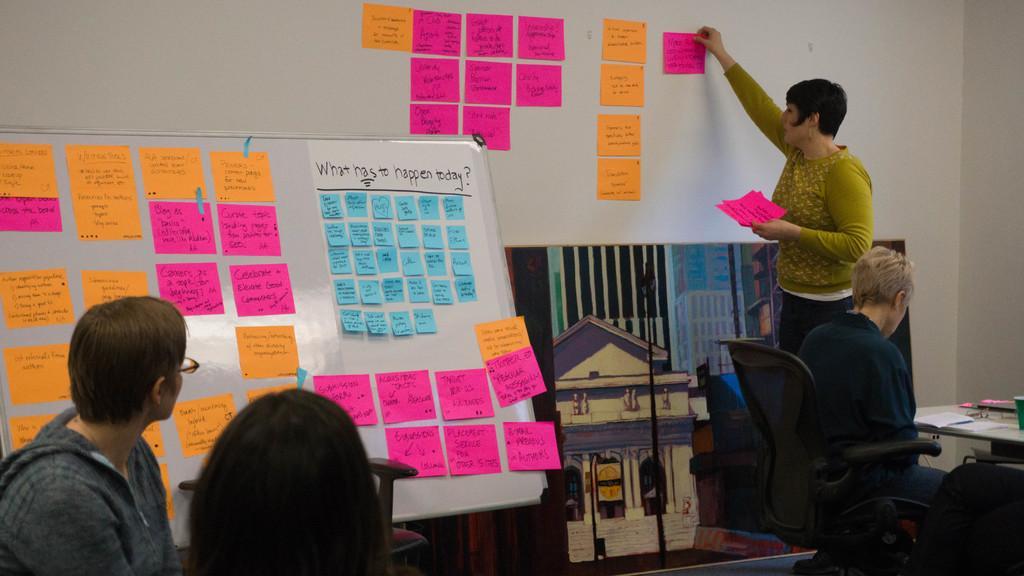In one or two sentences, can you explain what this image depicts? This picture might be taken inside the room. In this image, on the left corner, we can see two persons. On the right side, we can see a person sitting on the chair in front of the table, on that table there are some books, glass. On the right side, we can also see a woman standing and she is also holding paper in her two hands. In the background, we can see a white color board, on that white color board there are some papers which are in pink, yellow and blue color, we can also see a wall which is in white color and a painting which is attached to a wall. 